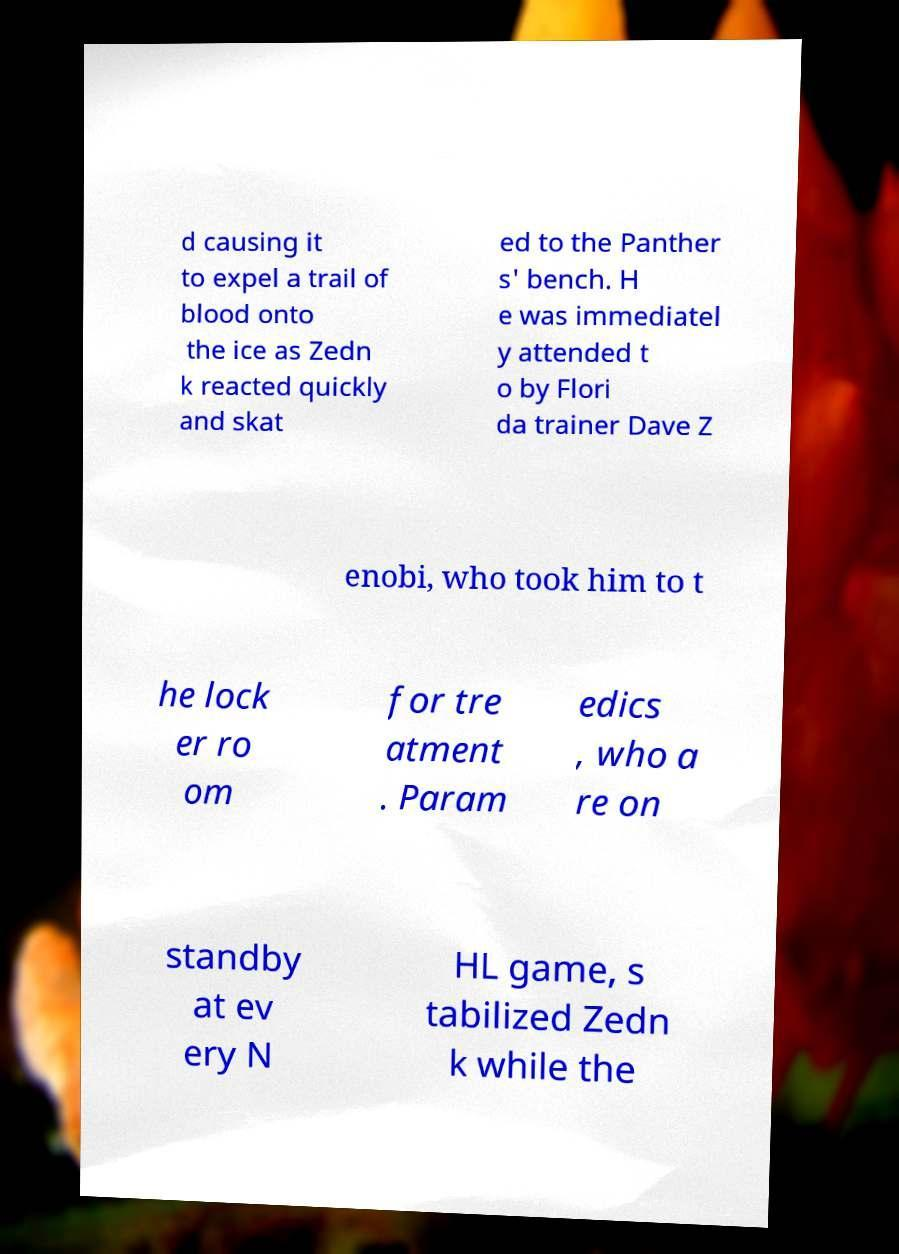There's text embedded in this image that I need extracted. Can you transcribe it verbatim? d causing it to expel a trail of blood onto the ice as Zedn k reacted quickly and skat ed to the Panther s' bench. H e was immediatel y attended t o by Flori da trainer Dave Z enobi, who took him to t he lock er ro om for tre atment . Param edics , who a re on standby at ev ery N HL game, s tabilized Zedn k while the 